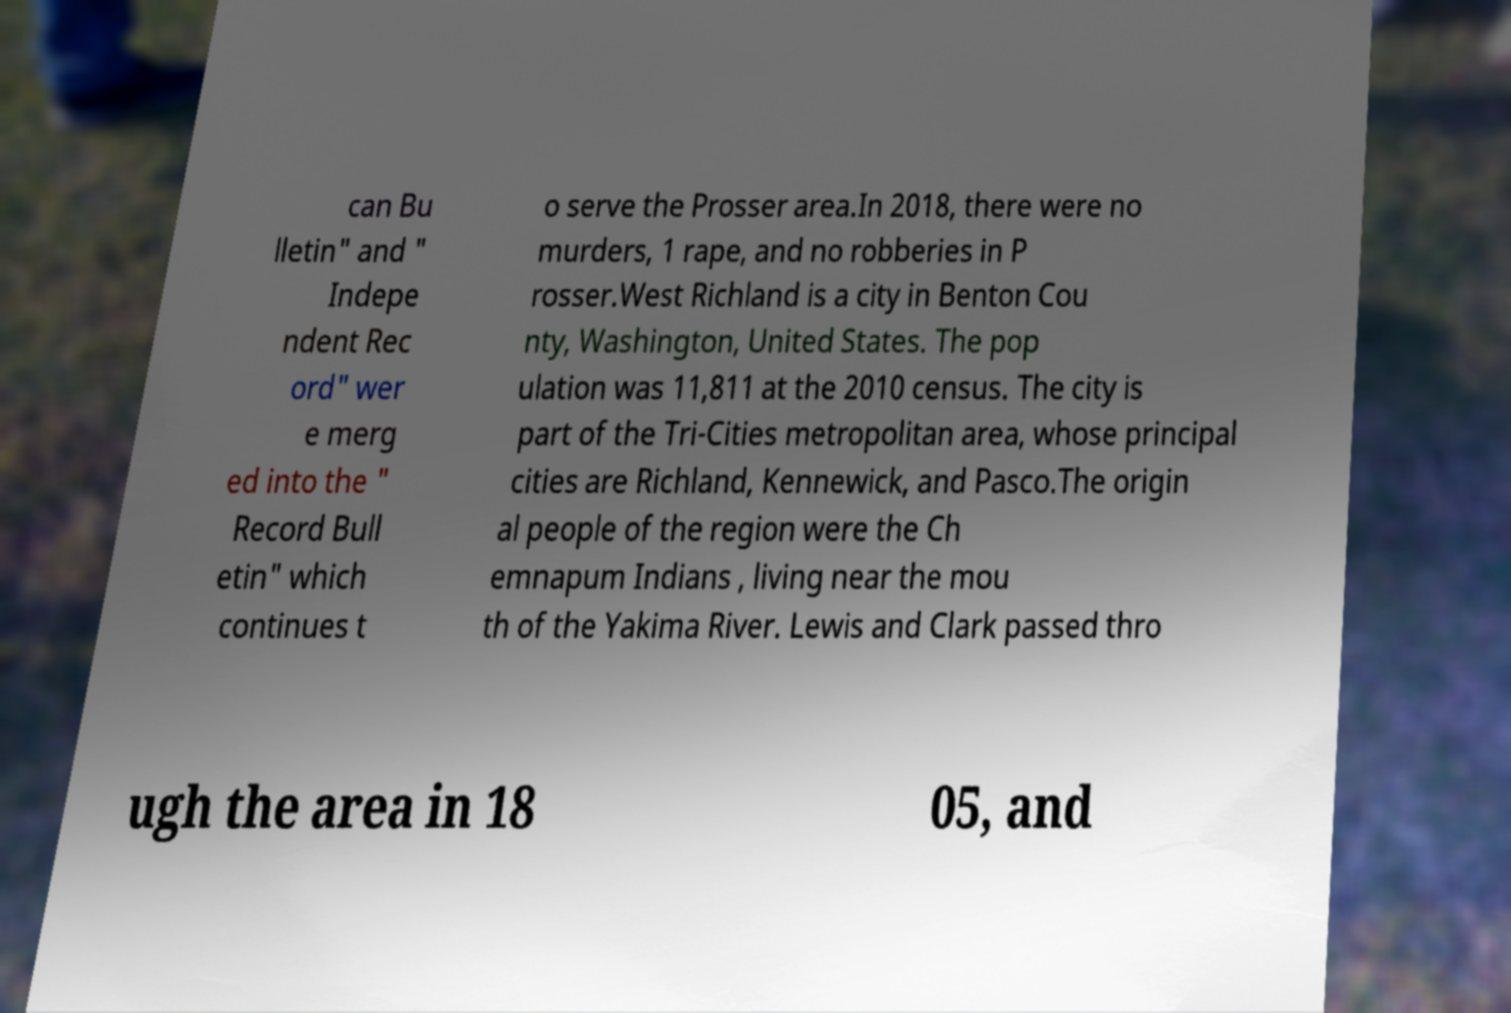What messages or text are displayed in this image? I need them in a readable, typed format. can Bu lletin" and " Indepe ndent Rec ord" wer e merg ed into the " Record Bull etin" which continues t o serve the Prosser area.In 2018, there were no murders, 1 rape, and no robberies in P rosser.West Richland is a city in Benton Cou nty, Washington, United States. The pop ulation was 11,811 at the 2010 census. The city is part of the Tri-Cities metropolitan area, whose principal cities are Richland, Kennewick, and Pasco.The origin al people of the region were the Ch emnapum Indians , living near the mou th of the Yakima River. Lewis and Clark passed thro ugh the area in 18 05, and 